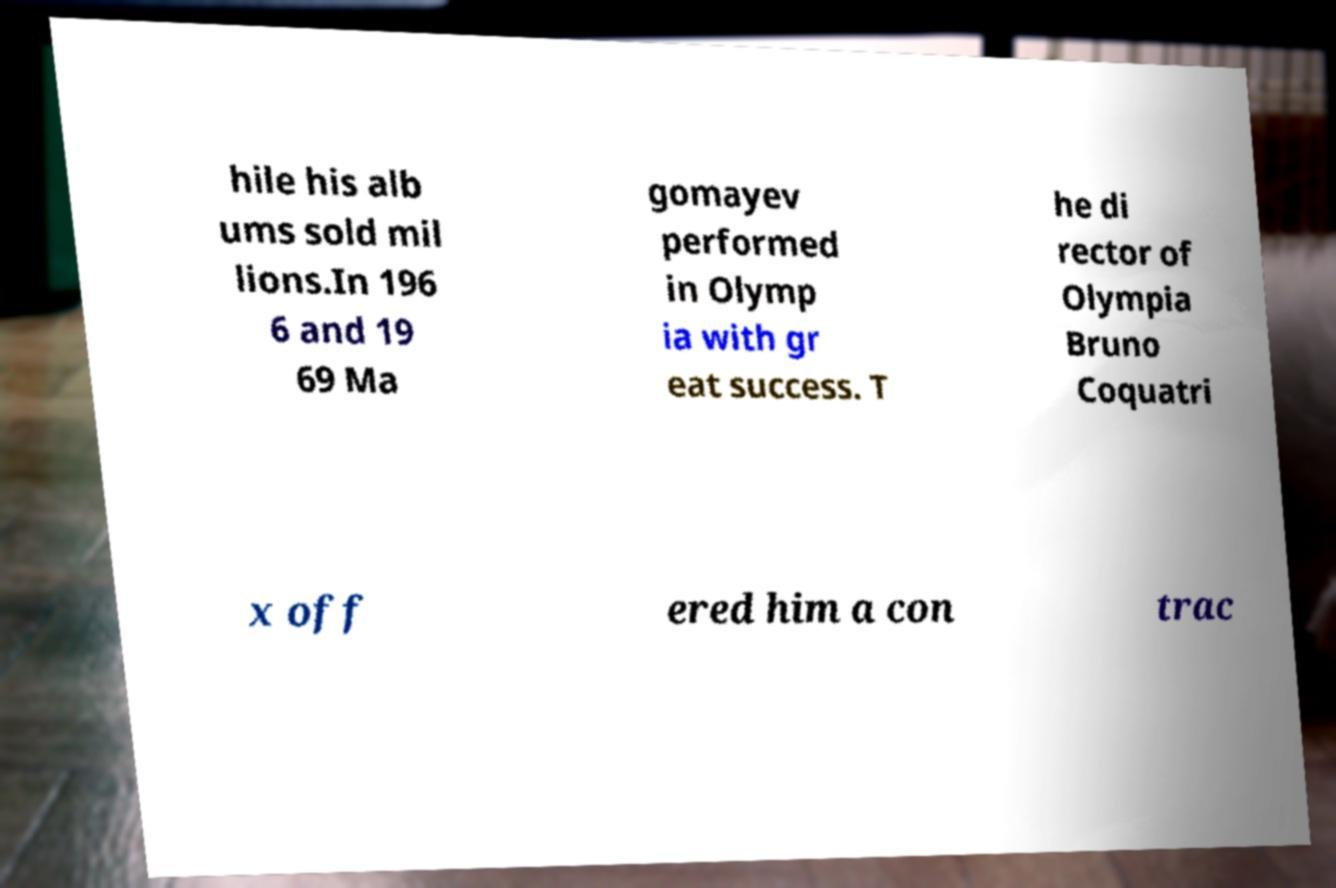Can you accurately transcribe the text from the provided image for me? hile his alb ums sold mil lions.In 196 6 and 19 69 Ma gomayev performed in Olymp ia with gr eat success. T he di rector of Olympia Bruno Coquatri x off ered him a con trac 